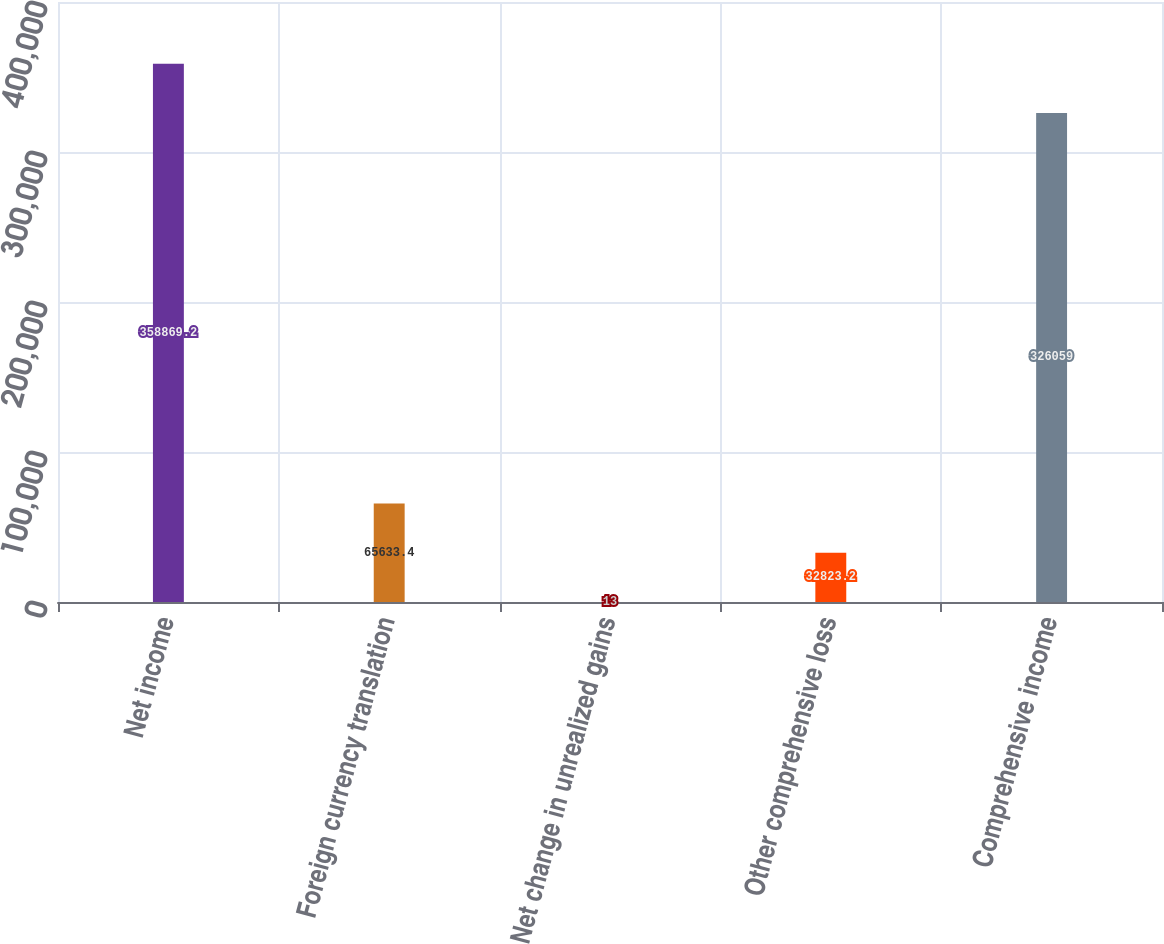<chart> <loc_0><loc_0><loc_500><loc_500><bar_chart><fcel>Net income<fcel>Foreign currency translation<fcel>Net change in unrealized gains<fcel>Other comprehensive loss<fcel>Comprehensive income<nl><fcel>358869<fcel>65633.4<fcel>13<fcel>32823.2<fcel>326059<nl></chart> 